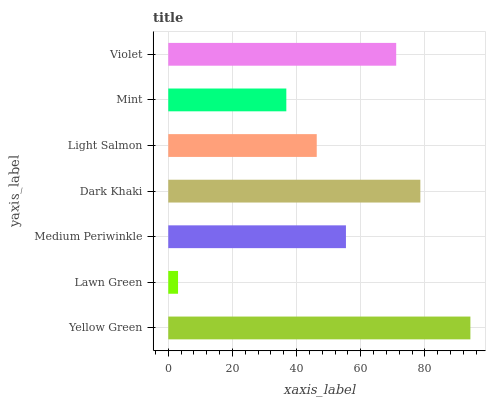Is Lawn Green the minimum?
Answer yes or no. Yes. Is Yellow Green the maximum?
Answer yes or no. Yes. Is Medium Periwinkle the minimum?
Answer yes or no. No. Is Medium Periwinkle the maximum?
Answer yes or no. No. Is Medium Periwinkle greater than Lawn Green?
Answer yes or no. Yes. Is Lawn Green less than Medium Periwinkle?
Answer yes or no. Yes. Is Lawn Green greater than Medium Periwinkle?
Answer yes or no. No. Is Medium Periwinkle less than Lawn Green?
Answer yes or no. No. Is Medium Periwinkle the high median?
Answer yes or no. Yes. Is Medium Periwinkle the low median?
Answer yes or no. Yes. Is Dark Khaki the high median?
Answer yes or no. No. Is Light Salmon the low median?
Answer yes or no. No. 